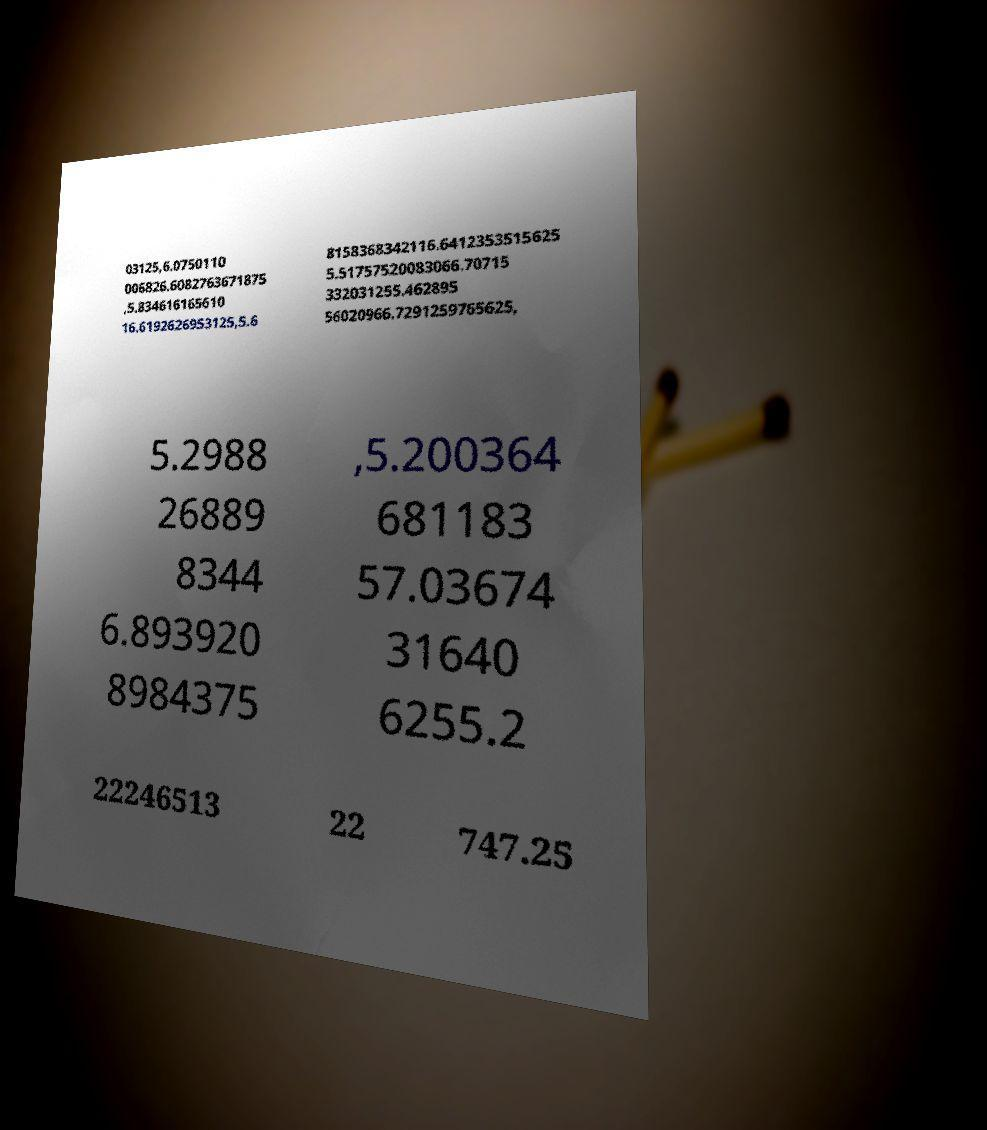What messages or text are displayed in this image? I need them in a readable, typed format. 03125,6.0750110 006826.6082763671875 ,5.834616165610 16.6192626953125,5.6 8158368342116.6412353515625 5.51757520083066.70715 332031255.462895 56020966.7291259765625, 5.2988 26889 8344 6.893920 8984375 ,5.200364 681183 57.03674 31640 6255.2 22246513 22 747.25 